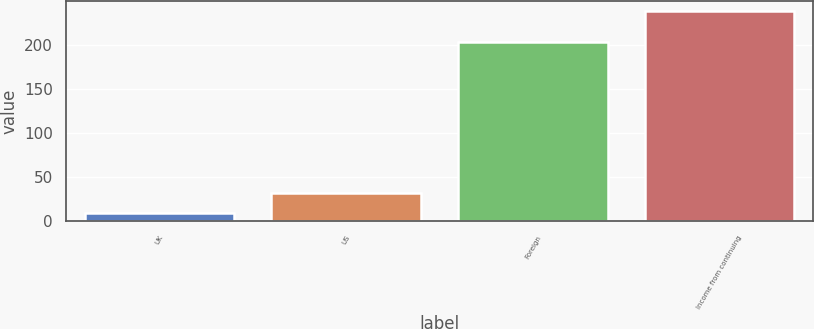Convert chart to OTSL. <chart><loc_0><loc_0><loc_500><loc_500><bar_chart><fcel>UK<fcel>US<fcel>Foreign<fcel>Income from continuing<nl><fcel>8.9<fcel>31.79<fcel>202.8<fcel>237.8<nl></chart> 